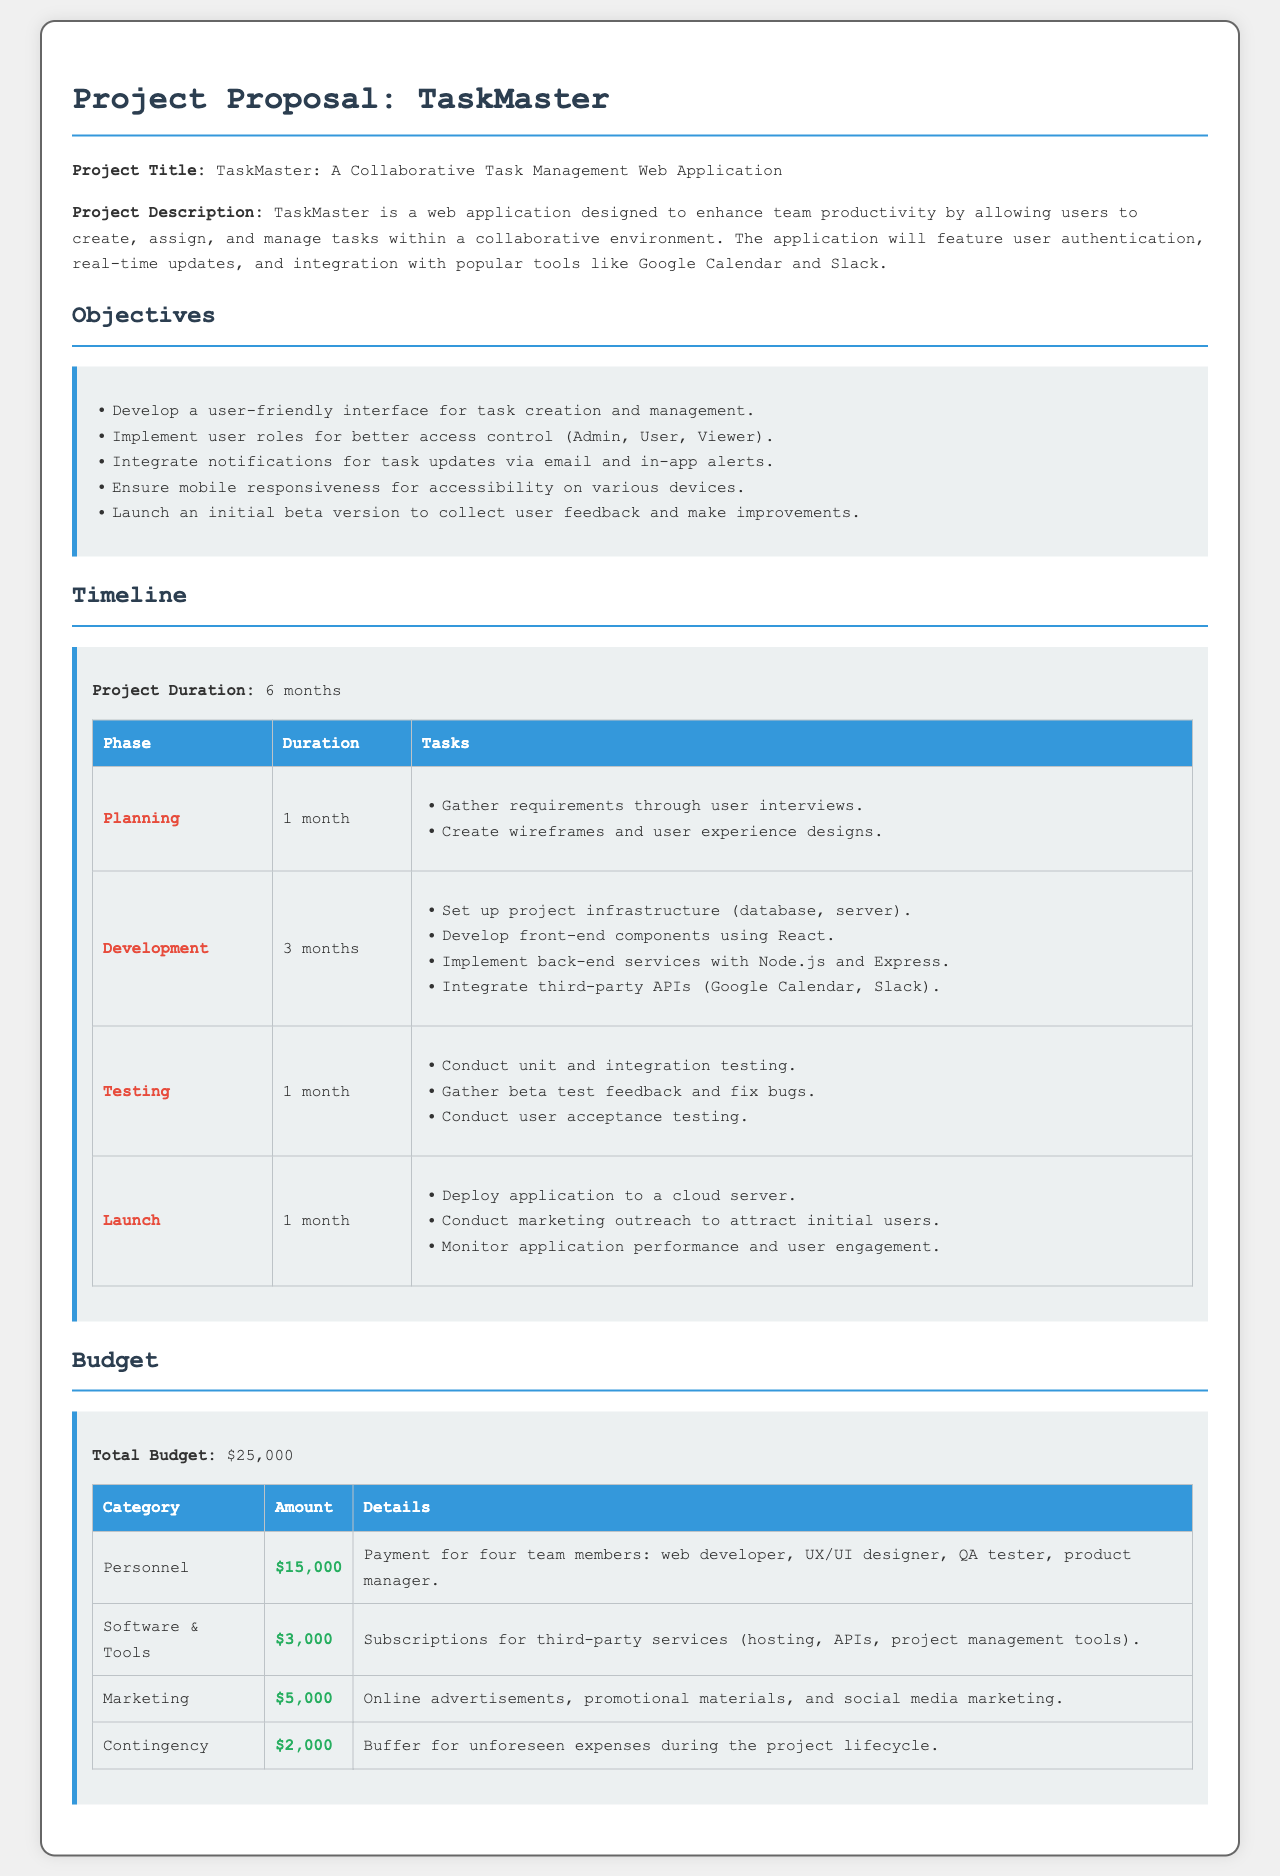What is the project title? The project title is explicitly stated in the document as "TaskMaster: A Collaborative Task Management Web Application."
Answer: TaskMaster: A Collaborative Task Management Web Application What is the total budget? The total budget is specified in the document under the Budget section, which totals to $25,000.
Answer: $25,000 How long is the project duration? The project duration is mentioned in the Timeline section, which states that it will last for 6 months.
Answer: 6 months What percentage of the budget is allocated for personnel? The personnel budget of $15,000 out of a total of $25,000 indicates that 60% of the budget is allocated for personnel.
Answer: 60% What is one feature of the TaskMaster application? The objectives section lists multiple features, one of which is a "user-friendly interface for task creation and management."
Answer: user-friendly interface for task creation and management During which phase does user acceptance testing occur? User acceptance testing is specifically mentioned as part of the testing phase in the Timeline section.
Answer: Testing What are the two third-party tools integrated into the application? The document mentions "Google Calendar and Slack" as the two third-party tools that will be integrated.
Answer: Google Calendar and Slack What is included in the marketing budget category? The marketing budget includes "online advertisements, promotional materials, and social media marketing," which are all detailed in the document.
Answer: online advertisements, promotional materials, and social media marketing What is the duration of the development phase? The development phase is listed as lasting for 3 months in the Timeline section.
Answer: 3 months 